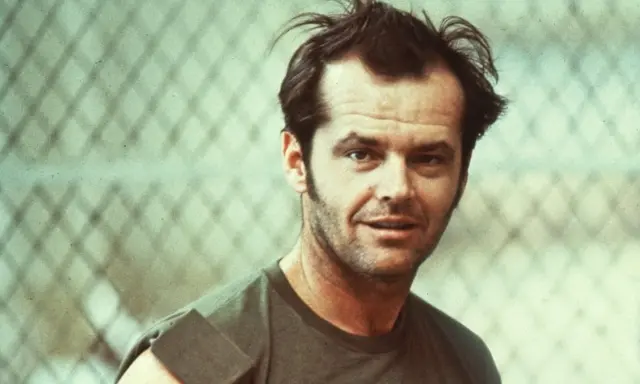How does the setting contribute to the overall mood of the photograph? The chain-link fence in the background adds a raw, unpolished element to the image, evoking a sense of being in a less refined, perhaps urban environment. This setting, combined with the faded colors and the subject's casual dress, contributes to a mood of rugged authenticity and a bygone era, enhancing the emotional impact of the photograph. 